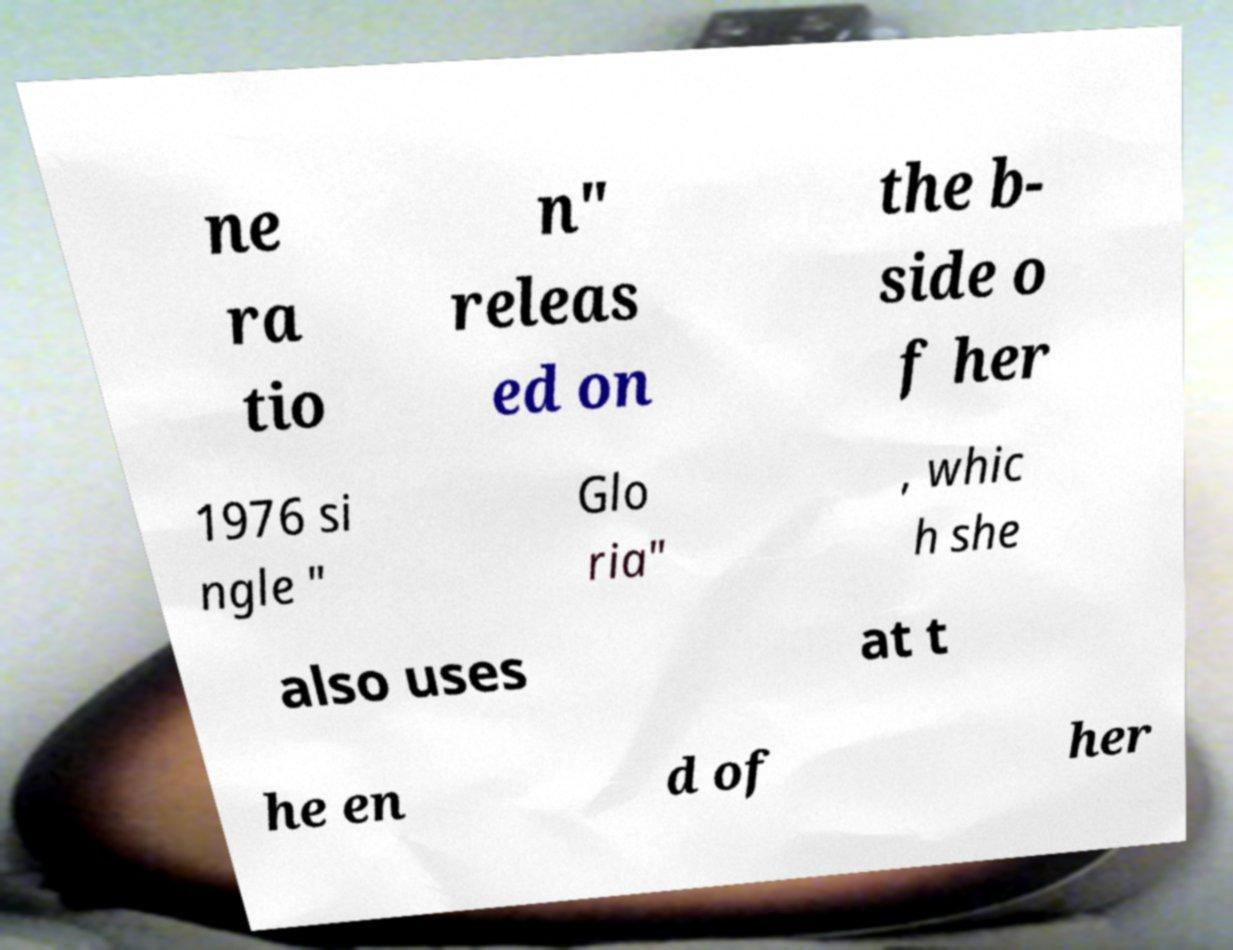I need the written content from this picture converted into text. Can you do that? ne ra tio n" releas ed on the b- side o f her 1976 si ngle " Glo ria" , whic h she also uses at t he en d of her 